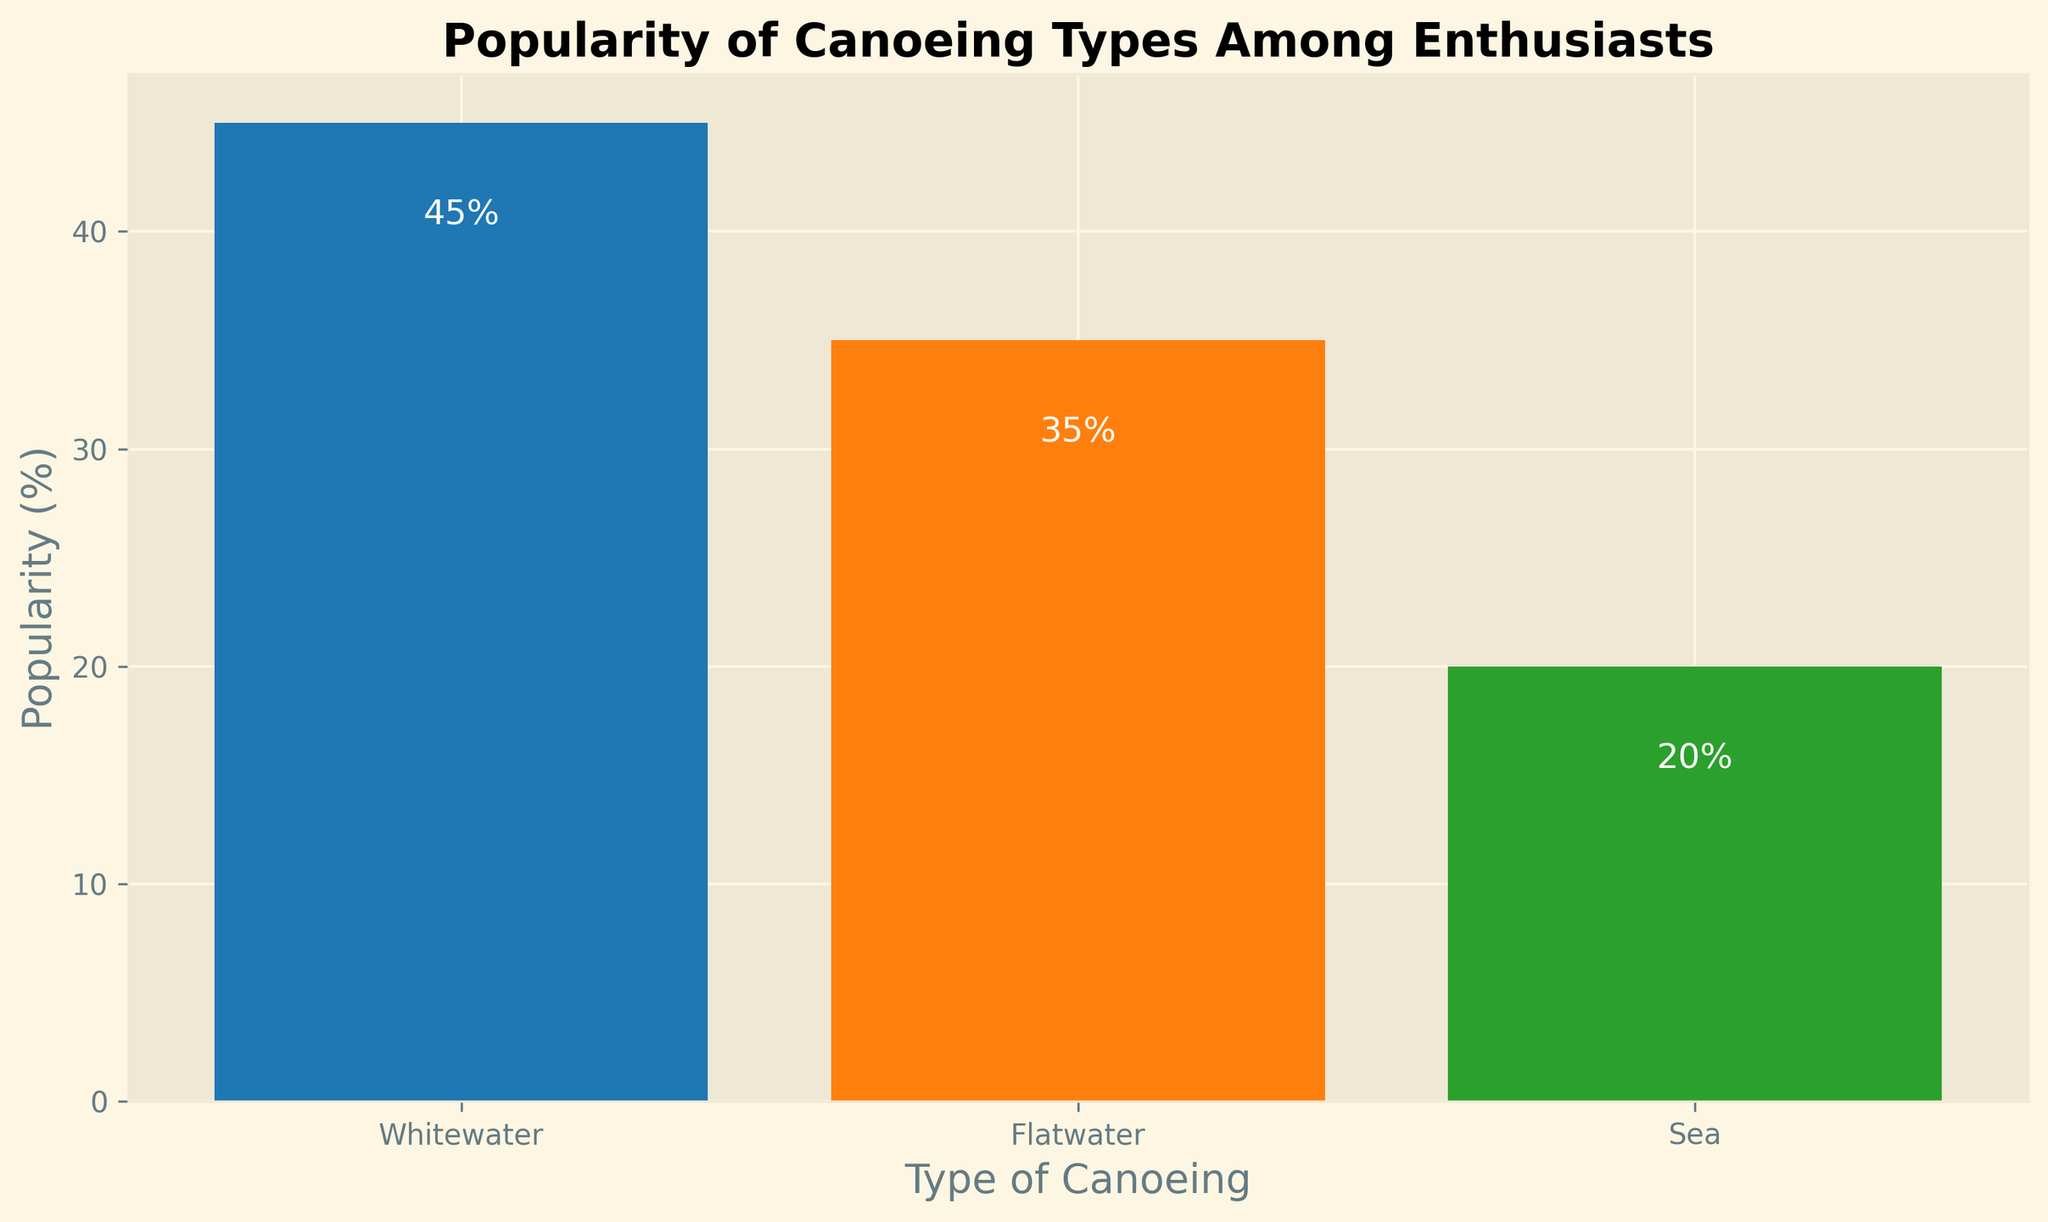Which type of canoeing is the most popular? By looking at the height of the bars, Whitewater canoeing has the tallest bar.
Answer: Whitewater Which type of canoeing is the least popular? By comparing the heights of the bars, Sea canoeing has the shortest bar.
Answer: Sea How much more popular is Whitewater canoeing compared to Sea canoeing? The popularity of Whitewater is 45%, and for Sea, it is 20%. The difference is 45% - 20% = 25%.
Answer: 25% What is the total popularity percentage for Flatwater and Sea canoeing? Flatwater canoeing has a popularity of 35%, and Sea canoeing has 20%. The total is 35% + 20% = 55%.
Answer: 55% What’s the average popularity percentage for all types of canoeing? The popularity percentages are 45%, 35%, and 20%. The sum is 45% + 35% + 20% = 100%. The average is 100% / 3 = 33.33%.
Answer: 33.33% Which two types of canoeing together have a higher combined popularity than the other single type? Comparing the combinations, Whitewater (45%) + Sea (20%) = 65% which is higher than Flatwater (35%) alone, and Flatwater (35%) + Sea (20%) = 55% which is higher than Whitewater (45%) alone. Whitewater and Flatwater together is 45% + 35% = 80%, which is higher than any single type.
Answer: Whitewater and Flatwater Which type of canoeing is exactly 15% more popular than Sea canoeing? Sea canoeing has 20%, and adding 15% results in 20% + 15% = 35%. This matches the popularity of Flatwater canoeing.
Answer: Flatwater Which two types of canoeing combined have equal popularity to Whitewater canoeing? The popularity of Whitewater is 45%. Summing Flatwater (35%) and Sea (20%) yields 35% + 20% = 55%, which is not equal. Only one possible combination is Flatwater (35%) and Sea (20%), which make 35% + 20% = 55%. Therefore, there is no exact match for 45%.
Answer: None What is the difference in popularity between the most and the least popular types of canoeing? Whitewater is the most popular at 45%, and Sea is the least popular at 20%. The difference is 45% - 20% = 25%.
Answer: 25% Which type of canoeing has an orange-colored bar? Referring to the visual attribute, Flatwater canoeing has an orange-colored bar.
Answer: Flatwater 